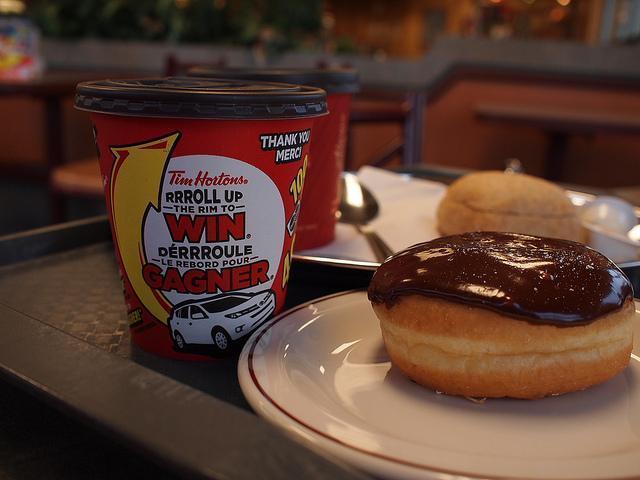How many donuts are on the plate?
Give a very brief answer. 1. How many donuts are in the photo?
Give a very brief answer. 2. How many cups can be seen?
Give a very brief answer. 2. 